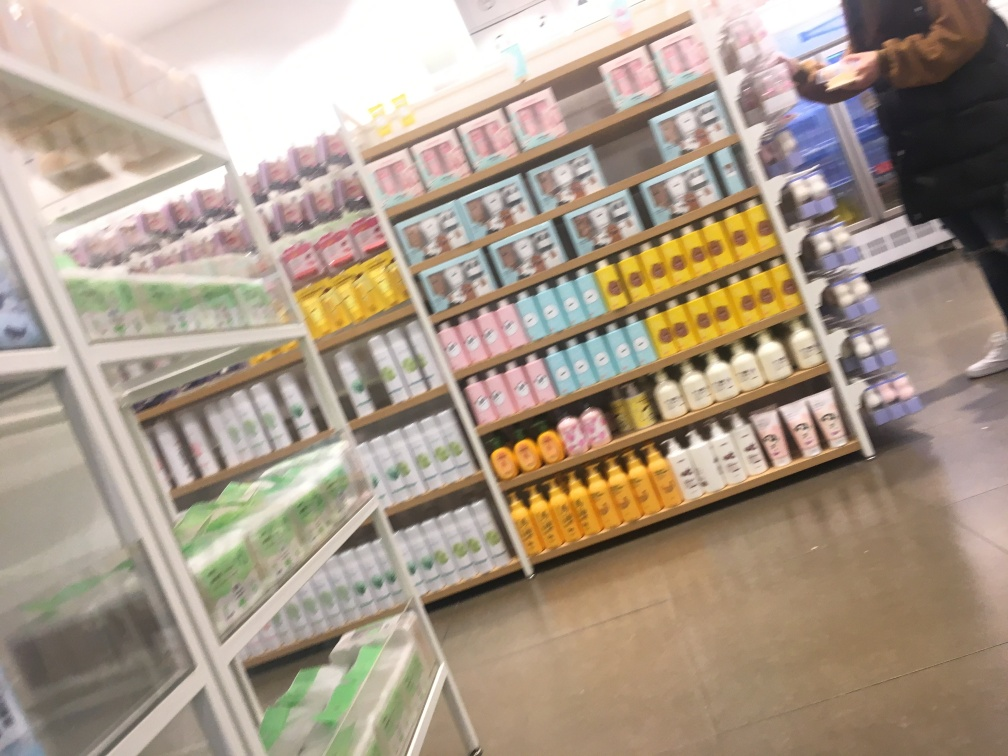Can you tell something about the lighting in the store? Although the image is unclear, the lighting appears to be typical of a retail environment, with bright and even illumination intended to highlight the products on the shelves without creating strong shadows. Is the store crowded? From what can be seen in the blurred image, the store doesn't appear to be very crowded. There seems to be only one person visible, standing to the right, which suggests either a moment of low customer traffic or a focus on a more individual service experience. 